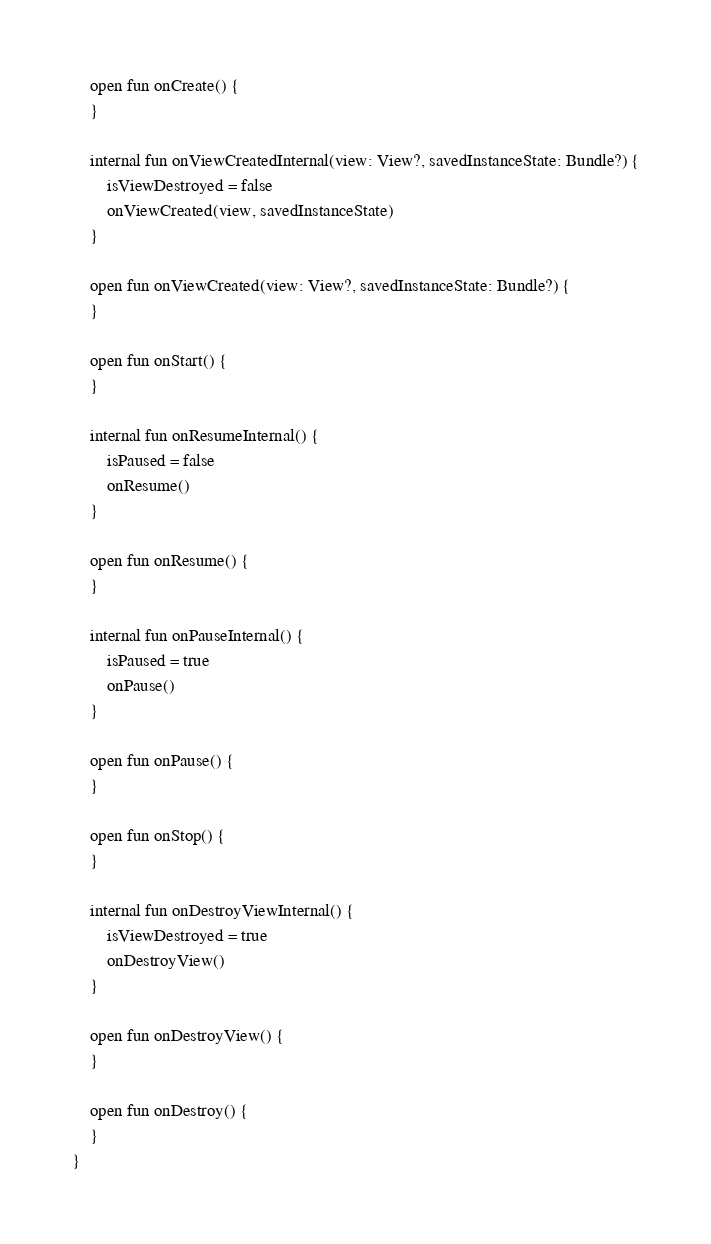<code> <loc_0><loc_0><loc_500><loc_500><_Kotlin_>    open fun onCreate() {
    }

    internal fun onViewCreatedInternal(view: View?, savedInstanceState: Bundle?) {
        isViewDestroyed = false
        onViewCreated(view, savedInstanceState)
    }

    open fun onViewCreated(view: View?, savedInstanceState: Bundle?) {
    }

    open fun onStart() {
    }

    internal fun onResumeInternal() {
        isPaused = false
        onResume()
    }

    open fun onResume() {
    }

    internal fun onPauseInternal() {
        isPaused = true
        onPause()
    }

    open fun onPause() {
    }

    open fun onStop() {
    }

    internal fun onDestroyViewInternal() {
        isViewDestroyed = true
        onDestroyView()
    }

    open fun onDestroyView() {
    }

    open fun onDestroy() {
    }
}</code> 